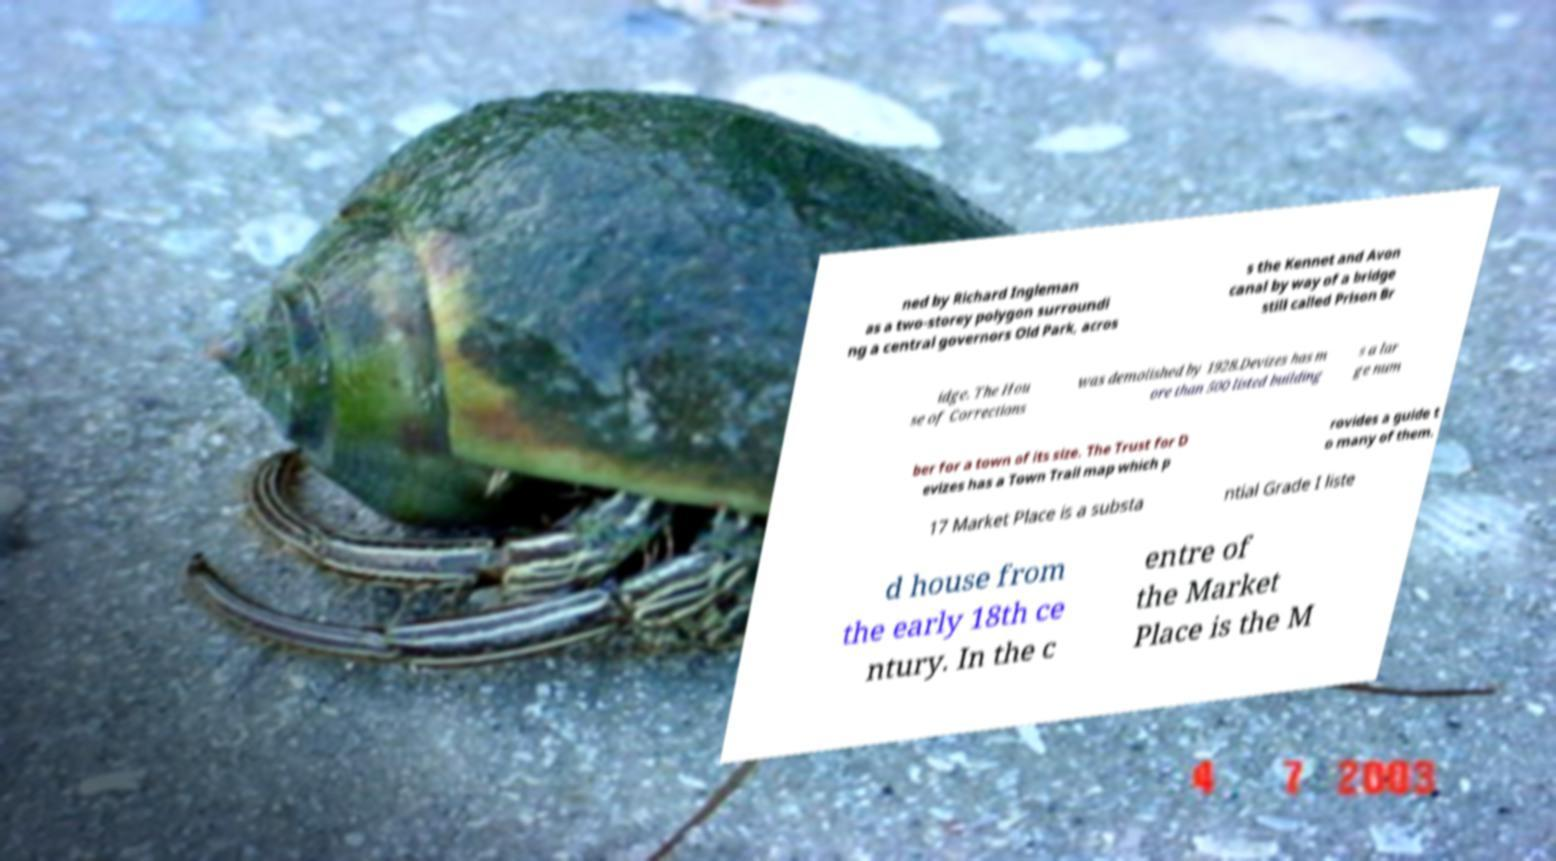I need the written content from this picture converted into text. Can you do that? ned by Richard Ingleman as a two-storey polygon surroundi ng a central governors Old Park, acros s the Kennet and Avon canal by way of a bridge still called Prison Br idge. The Hou se of Corrections was demolished by 1928.Devizes has m ore than 500 listed building s a lar ge num ber for a town of its size. The Trust for D evizes has a Town Trail map which p rovides a guide t o many of them. 17 Market Place is a substa ntial Grade I liste d house from the early 18th ce ntury. In the c entre of the Market Place is the M 